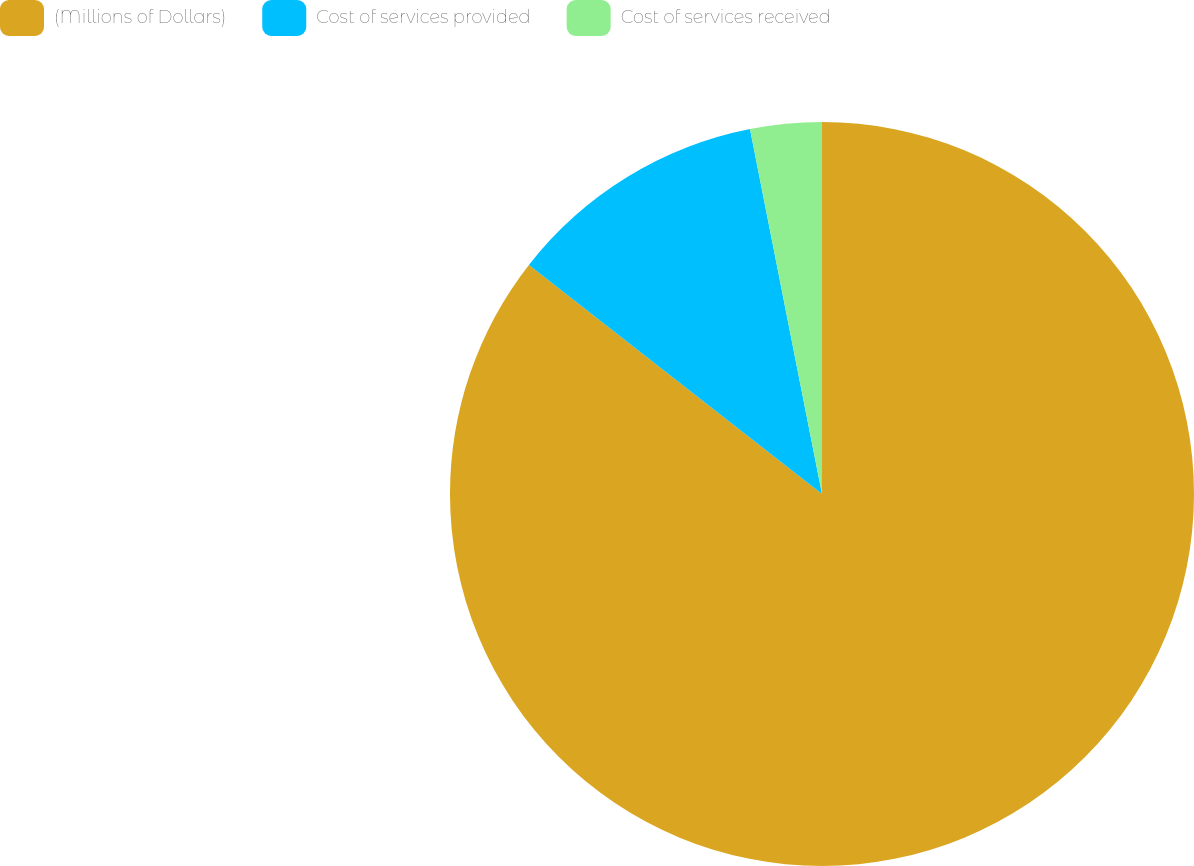Convert chart. <chart><loc_0><loc_0><loc_500><loc_500><pie_chart><fcel>(Millions of Dollars)<fcel>Cost of services provided<fcel>Cost of services received<nl><fcel>85.56%<fcel>11.34%<fcel>3.1%<nl></chart> 